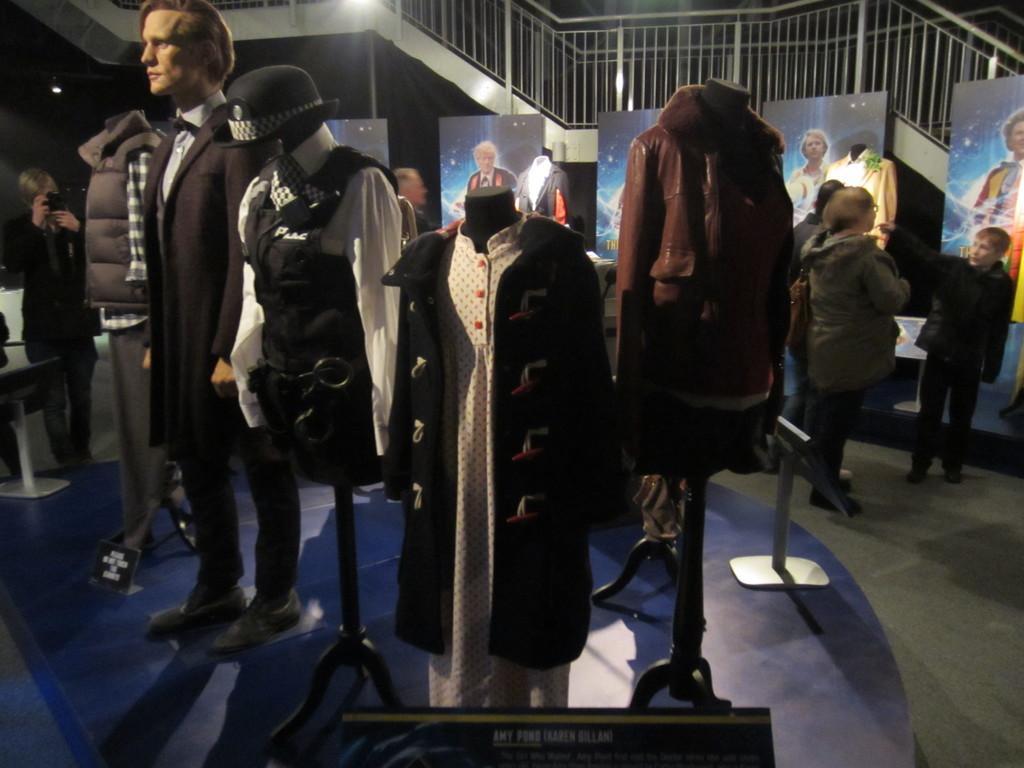Can you describe this image briefly? It is an exhibition there are different types of clothes kept in an expo and the people are watching the clothes and the clothes are worn by the mannequin,behind the mannequin is there are big posters of few people and in the background there are stairs. 